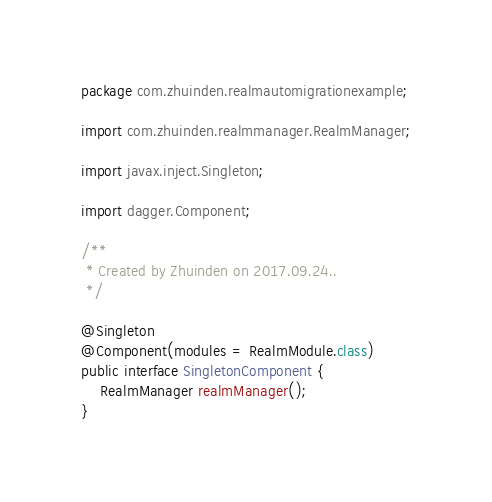Convert code to text. <code><loc_0><loc_0><loc_500><loc_500><_Java_>package com.zhuinden.realmautomigrationexample;

import com.zhuinden.realmmanager.RealmManager;

import javax.inject.Singleton;

import dagger.Component;

/**
 * Created by Zhuinden on 2017.09.24..
 */

@Singleton
@Component(modules = RealmModule.class)
public interface SingletonComponent {
    RealmManager realmManager();
}
</code> 